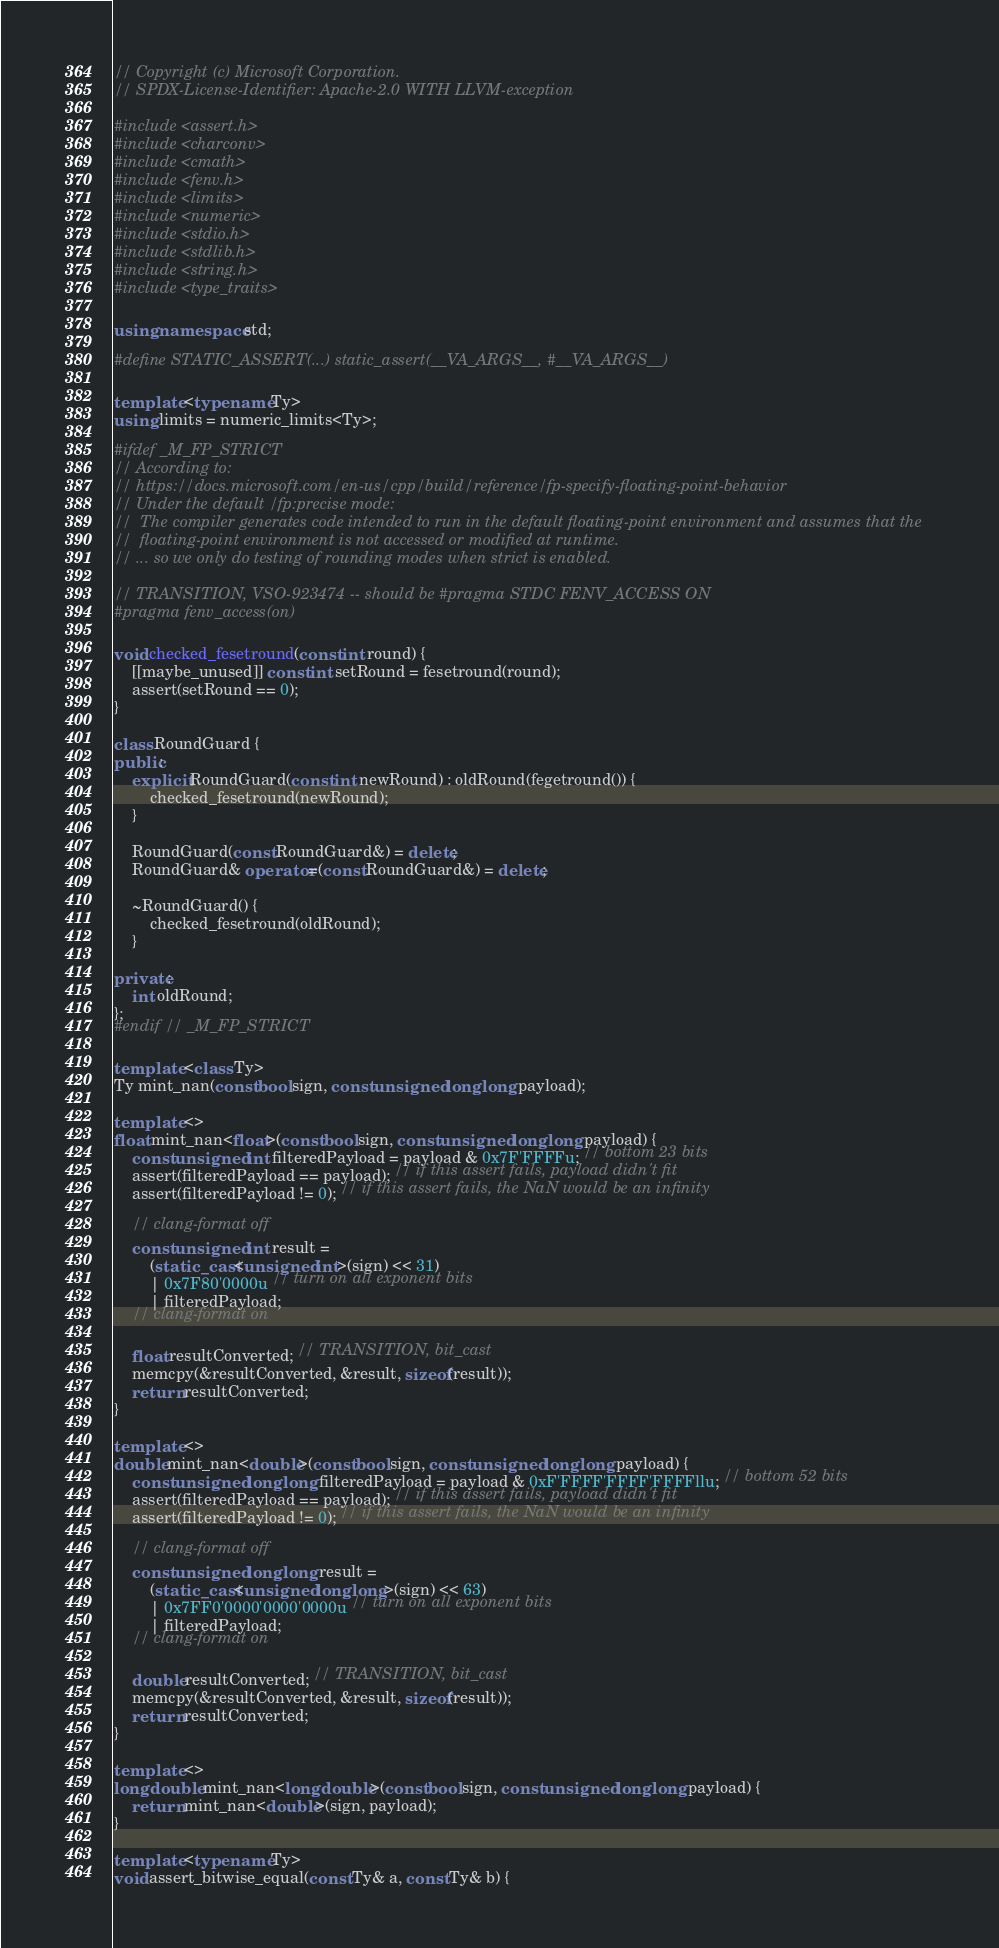<code> <loc_0><loc_0><loc_500><loc_500><_C++_>// Copyright (c) Microsoft Corporation.
// SPDX-License-Identifier: Apache-2.0 WITH LLVM-exception

#include <assert.h>
#include <charconv>
#include <cmath>
#include <fenv.h>
#include <limits>
#include <numeric>
#include <stdio.h>
#include <stdlib.h>
#include <string.h>
#include <type_traits>

using namespace std;

#define STATIC_ASSERT(...) static_assert(__VA_ARGS__, #__VA_ARGS__)

template <typename Ty>
using limits = numeric_limits<Ty>;

#ifdef _M_FP_STRICT
// According to:
// https://docs.microsoft.com/en-us/cpp/build/reference/fp-specify-floating-point-behavior
// Under the default /fp:precise mode:
//  The compiler generates code intended to run in the default floating-point environment and assumes that the
//  floating-point environment is not accessed or modified at runtime.
// ... so we only do testing of rounding modes when strict is enabled.

// TRANSITION, VSO-923474 -- should be #pragma STDC FENV_ACCESS ON
#pragma fenv_access(on)

void checked_fesetround(const int round) {
    [[maybe_unused]] const int setRound = fesetround(round);
    assert(setRound == 0);
}

class RoundGuard {
public:
    explicit RoundGuard(const int newRound) : oldRound(fegetround()) {
        checked_fesetround(newRound);
    }

    RoundGuard(const RoundGuard&) = delete;
    RoundGuard& operator=(const RoundGuard&) = delete;

    ~RoundGuard() {
        checked_fesetround(oldRound);
    }

private:
    int oldRound;
};
#endif // _M_FP_STRICT

template <class Ty>
Ty mint_nan(const bool sign, const unsigned long long payload);

template <>
float mint_nan<float>(const bool sign, const unsigned long long payload) {
    const unsigned int filteredPayload = payload & 0x7F'FFFFu; // bottom 23 bits
    assert(filteredPayload == payload); // if this assert fails, payload didn't fit
    assert(filteredPayload != 0); // if this assert fails, the NaN would be an infinity

    // clang-format off
    const unsigned int result =
        (static_cast<unsigned int>(sign) << 31)
        | 0x7F80'0000u // turn on all exponent bits
        | filteredPayload;
    // clang-format on

    float resultConverted; // TRANSITION, bit_cast
    memcpy(&resultConverted, &result, sizeof(result));
    return resultConverted;
}

template <>
double mint_nan<double>(const bool sign, const unsigned long long payload) {
    const unsigned long long filteredPayload = payload & 0xF'FFFF'FFFF'FFFFllu; // bottom 52 bits
    assert(filteredPayload == payload); // if this assert fails, payload didn't fit
    assert(filteredPayload != 0); // if this assert fails, the NaN would be an infinity

    // clang-format off
    const unsigned long long result =
        (static_cast<unsigned long long>(sign) << 63)
        | 0x7FF0'0000'0000'0000u // turn on all exponent bits
        | filteredPayload;
    // clang-format on

    double resultConverted; // TRANSITION, bit_cast
    memcpy(&resultConverted, &result, sizeof(result));
    return resultConverted;
}

template <>
long double mint_nan<long double>(const bool sign, const unsigned long long payload) {
    return mint_nan<double>(sign, payload);
}

template <typename Ty>
void assert_bitwise_equal(const Ty& a, const Ty& b) {</code> 